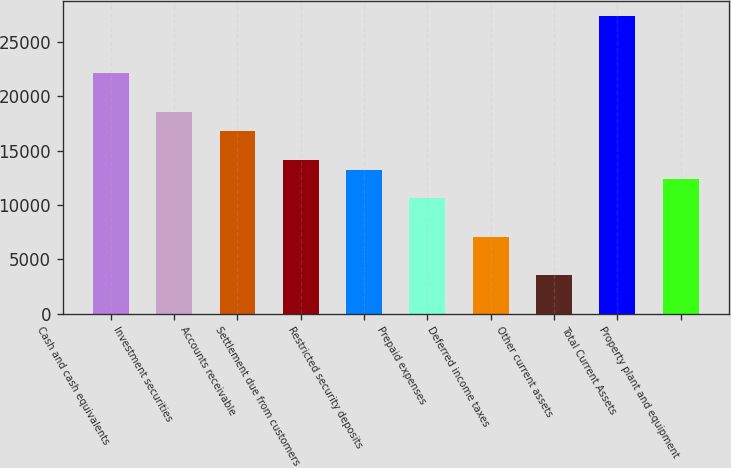<chart> <loc_0><loc_0><loc_500><loc_500><bar_chart><fcel>Cash and cash equivalents<fcel>Investment securities<fcel>Accounts receivable<fcel>Settlement due from customers<fcel>Restricted security deposits<fcel>Prepaid expenses<fcel>Deferred income taxes<fcel>Other current assets<fcel>Total Current Assets<fcel>Property plant and equipment<nl><fcel>22089.5<fcel>18555.5<fcel>16788.5<fcel>14138<fcel>13254.5<fcel>10604<fcel>7070<fcel>3536<fcel>27390.5<fcel>12371<nl></chart> 